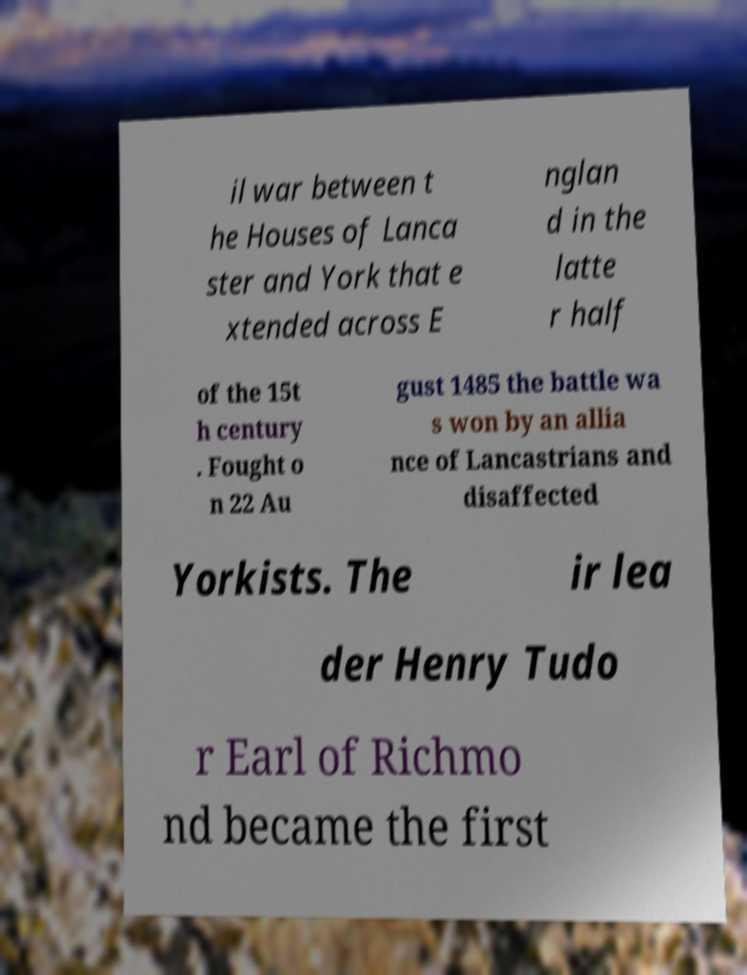Can you accurately transcribe the text from the provided image for me? il war between t he Houses of Lanca ster and York that e xtended across E nglan d in the latte r half of the 15t h century . Fought o n 22 Au gust 1485 the battle wa s won by an allia nce of Lancastrians and disaffected Yorkists. The ir lea der Henry Tudo r Earl of Richmo nd became the first 